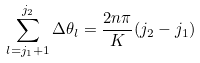Convert formula to latex. <formula><loc_0><loc_0><loc_500><loc_500>\sum _ { l = j _ { 1 } + 1 } ^ { j _ { 2 } } \Delta \theta _ { l } = \frac { 2 n \pi } { K } ( j _ { 2 } - j _ { 1 } )</formula> 